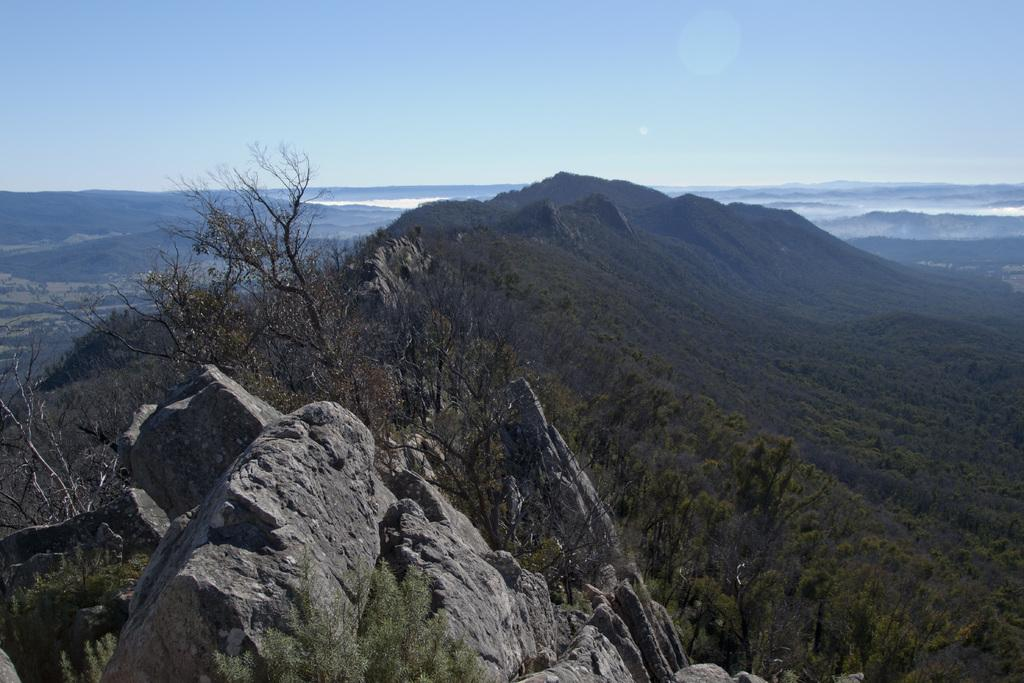What geographical feature is the main subject of the image? There is a big hill in the image. What can be seen on the hill? There are trees on the hill. How would you describe the sky at the top of the hill? The sky at the top of the hill is cloudy. What can be seen in the distance behind the hill? There is a sea visible in the background of the image. What song is being sung by the trees on the hill in the image? There is no indication in the image that the trees are singing a song, as trees do not have the ability to sing. 